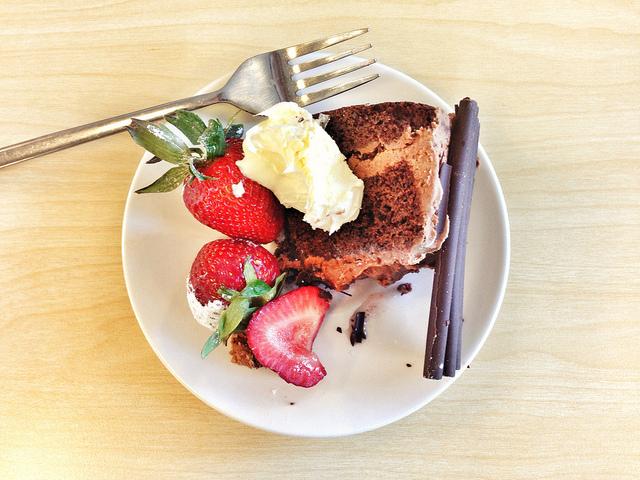What is the garnish on the far right?
Short answer required. Chocolate. Have the strawberries been hulled?
Write a very short answer. No. Can you see any fruits?
Short answer required. Yes. 